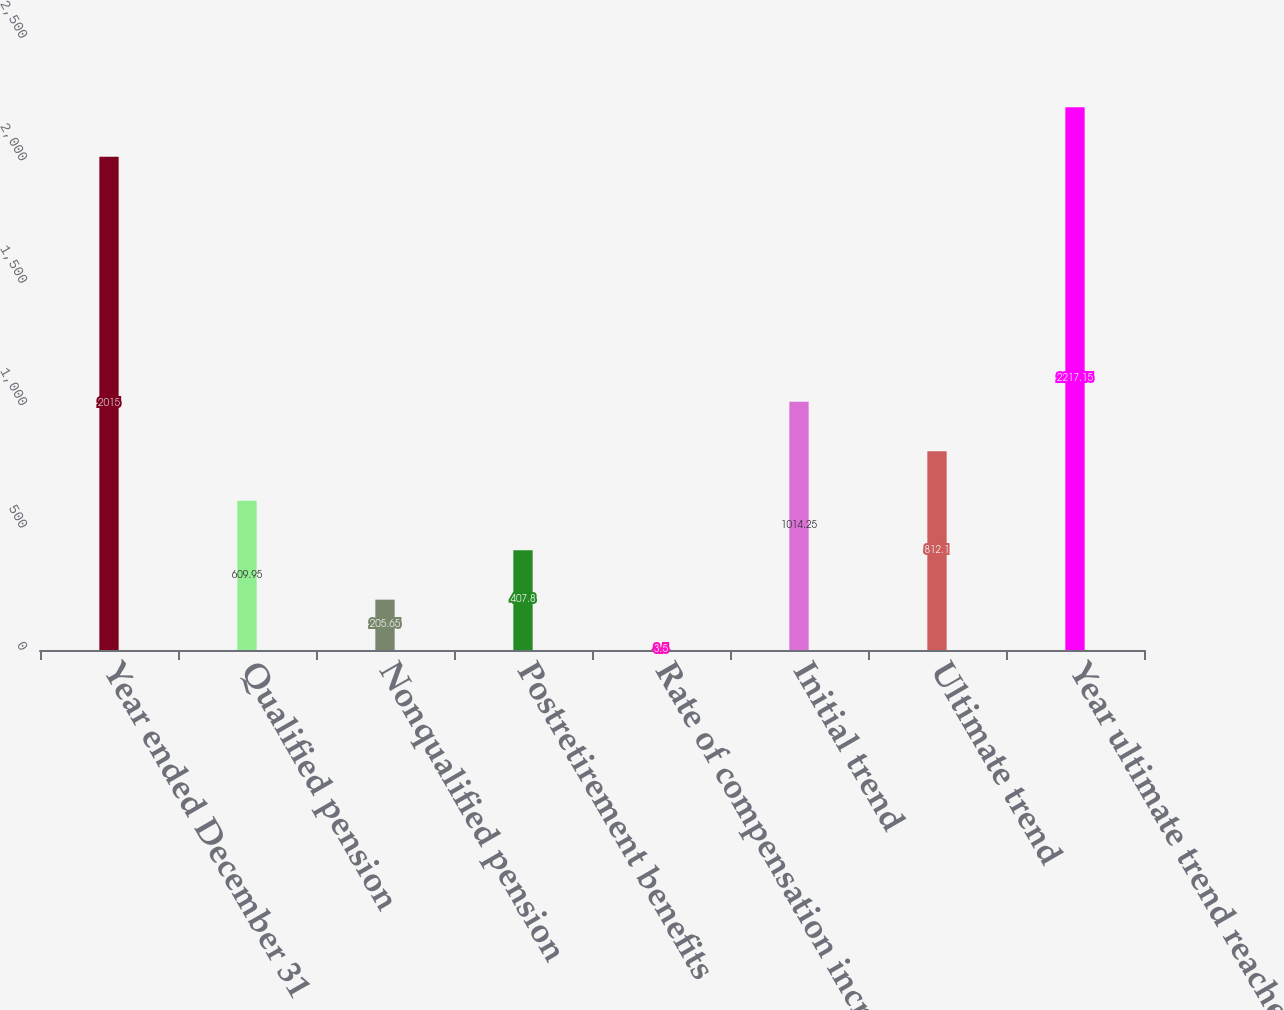Convert chart to OTSL. <chart><loc_0><loc_0><loc_500><loc_500><bar_chart><fcel>Year ended December 31<fcel>Qualified pension<fcel>Nonqualified pension<fcel>Postretirement benefits<fcel>Rate of compensation increase<fcel>Initial trend<fcel>Ultimate trend<fcel>Year ultimate trend reached<nl><fcel>2015<fcel>609.95<fcel>205.65<fcel>407.8<fcel>3.5<fcel>1014.25<fcel>812.1<fcel>2217.15<nl></chart> 